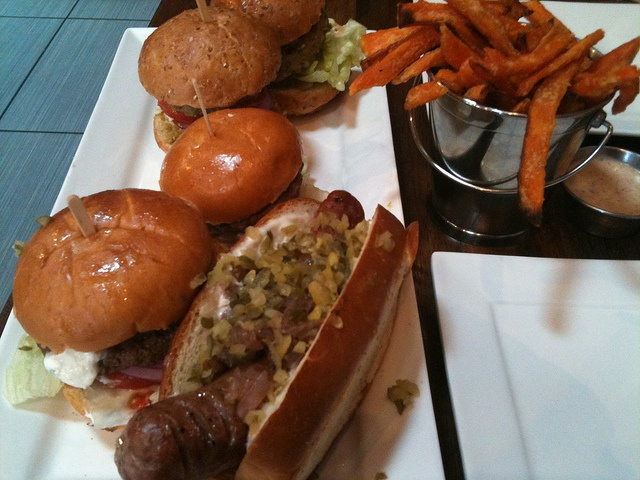Describe the objects in this image and their specific colors. I can see hot dog in teal, maroon, black, and brown tones, sandwich in teal, brown, maroon, salmon, and black tones, carrot in teal, maroon, brown, and black tones, sandwich in teal, brown, maroon, and black tones, and sandwich in teal, brown, maroon, salmon, and black tones in this image. 